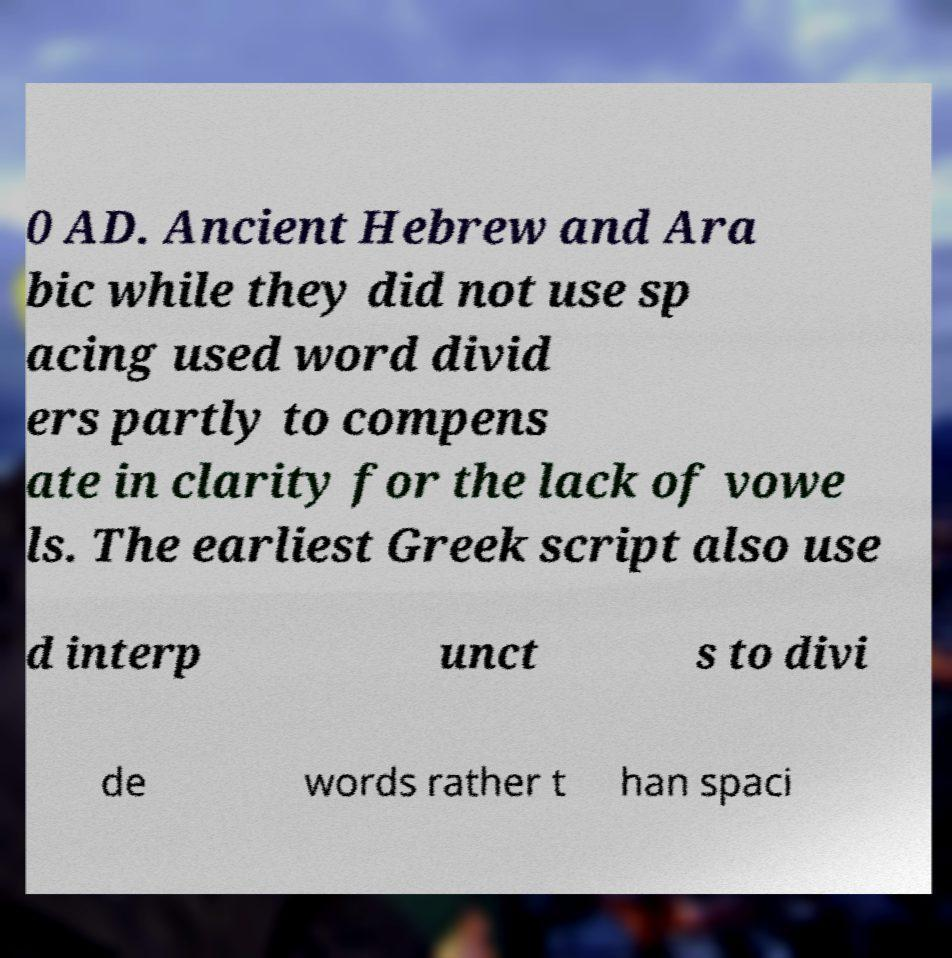Can you read and provide the text displayed in the image?This photo seems to have some interesting text. Can you extract and type it out for me? 0 AD. Ancient Hebrew and Ara bic while they did not use sp acing used word divid ers partly to compens ate in clarity for the lack of vowe ls. The earliest Greek script also use d interp unct s to divi de words rather t han spaci 